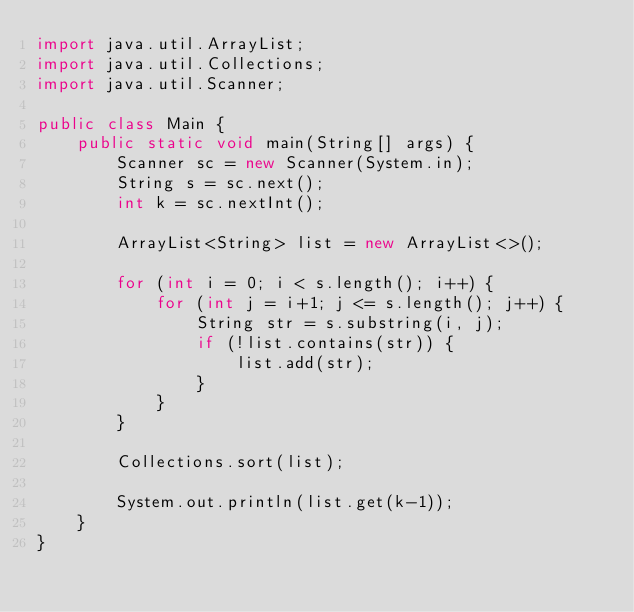Convert code to text. <code><loc_0><loc_0><loc_500><loc_500><_Java_>import java.util.ArrayList;
import java.util.Collections;
import java.util.Scanner;

public class Main {
    public static void main(String[] args) {
        Scanner sc = new Scanner(System.in);
        String s = sc.next();
        int k = sc.nextInt();

        ArrayList<String> list = new ArrayList<>();

        for (int i = 0; i < s.length(); i++) {
            for (int j = i+1; j <= s.length(); j++) {
                String str = s.substring(i, j);
                if (!list.contains(str)) {
                    list.add(str);
                }
            }
        }

        Collections.sort(list);

        System.out.println(list.get(k-1));
    }
}
</code> 